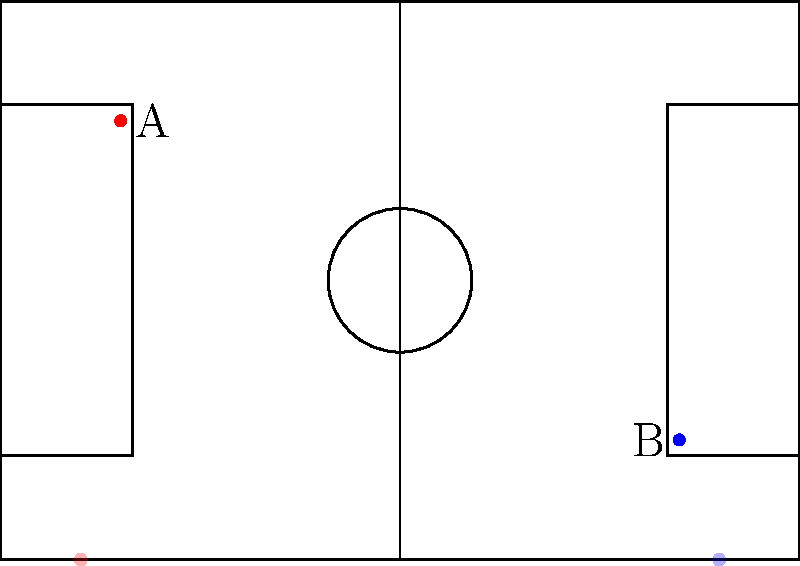Analyzing the heat maps and average positions (A and B) of the fullbacks shown in the diagram, which tactical system is more likely being employed by the team, and how does this impact the fullbacks' roles? To answer this question, we need to analyze the given information step-by-step:

1. Heat map analysis:
   - The red heat map is concentrated on the left side of the pitch, near the touchline.
   - The blue heat map is on the right side, also near the touchline.
   - Both heat maps show significant forward positioning.

2. Average positions:
   - Point A (red) is high up the pitch on the left side.
   - Point B (blue) is deeper on the right side.

3. Tactical implications:
   - The advanced positioning of both fullbacks suggests an attacking system.
   - The asymmetry in positions (one higher than the other) indicates a tactical approach where one fullback pushes forward more aggressively.

4. Likely tactical system:
   - This setup is characteristic of a 3-5-2 or 3-4-3 formation with wing-backs.
   - In these systems, fullbacks often play as wing-backs, providing width and attacking support.

5. Impact on fullbacks' roles:
   - The left fullback (A) plays a more attacking role, almost as an additional winger.
   - The right fullback (B) provides balance, staying slightly deeper but still offering width.
   - Both are expected to cover large areas of the pitch, contributing to both attack and defense.

6. Alternative interpretation:
   - This could also represent an asymmetric 4-3-3 or 4-2-3-1 with an inverted fullback on the right.

The most likely system, given the advanced and asymmetric positioning, is a 3-5-2 or 3-4-3 with attacking wing-backs.
Answer: 3-5-2 or 3-4-3 with attacking wing-backs; fullbacks play wider, more attacking roles with asymmetric positioning. 